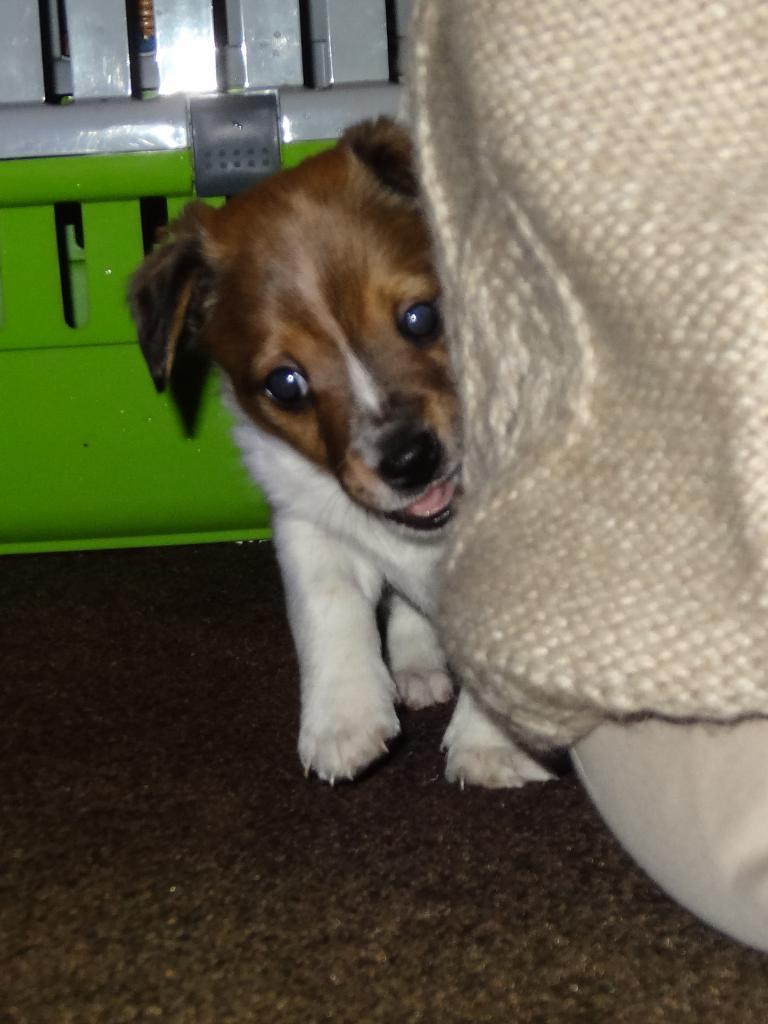Can you describe this image briefly? In this picture I can see a dog standing, there is a person sitting, and in the background there is an object. 